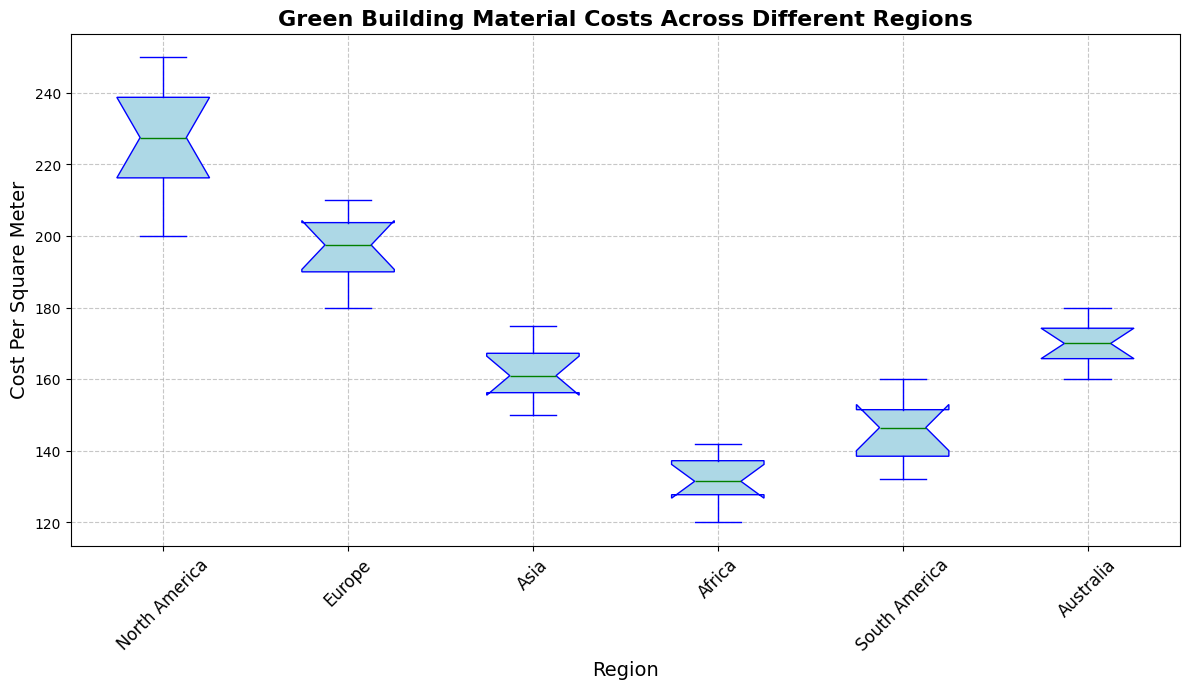Which region has the highest median cost per square meter? The median is shown by the green line in the middle of each box. The region with the highest green line is North America.
Answer: North America Which regions have a similar median cost per square meter? By comparing the green medians in each box, Europe and Australia have very close median values.
Answer: Europe and Australia Compare the spread of costs in North America and Africa. Which region has more variability? The spread is indicated by the height of the box and the length of the whiskers. North America's box and whiskers are much taller and longer than Africa's.
Answer: North America Which region has the smallest interquartile range? The interquartile range (IQR) is the middle 50% of data, represented by the height of the box. South America has the shortest box, indicating the smallest IQR.
Answer: South America Identify the region with the lowest maximum cost per square meter. The maximum cost is at the top end of the whisker. Africa has the lowest top whisker.
Answer: Africa How does the cost distribution in Asia compare to that in Australia? Asia's box is lower and shorter, indicating lower and less variable costs compared to Australia's larger spread and higher costs.
Answer: Asia has lower and less variable costs What are the approximate median costs per square meter for Europe and South America? Europe’s median is around 200, and South America’s is around 145. These values are found by looking at the green lines for each region.
Answer: Europe: 200, South America: 145 Which region contains more outliers, North America or Asia? Outliers are indicated by red points outside of the whiskers. North America has no outliers above or below the whiskers, while Asia similarly has none. Thus, neither region contains any outliers.
Answer: Neither 